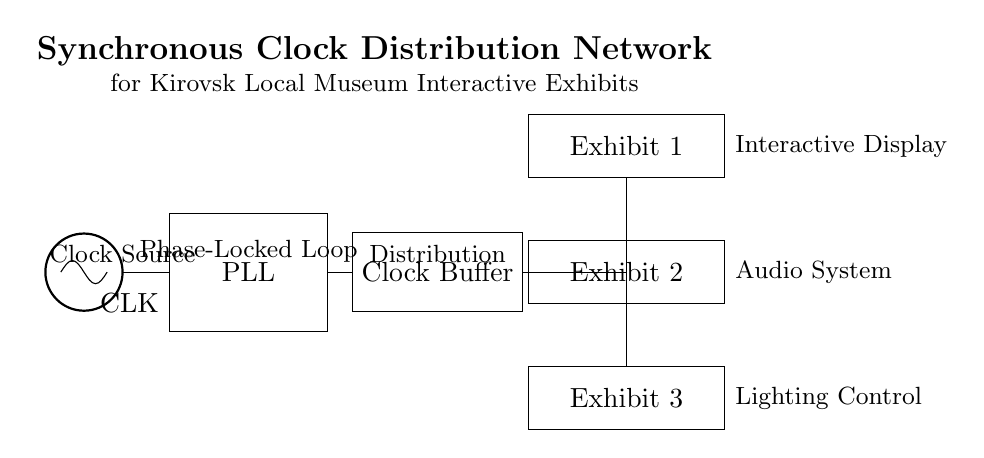What is the main source of the clock signal? The main source of the clock signal is the oscillator labeled "CLK". This component generates the clock signal used to synchronize operations in the circuit.
Answer: CLK What component is used for clock signal adjustment? The component responsible for clock signal adjustment in the circuit is the Phase-Locked Loop (PLL). The PLL synchronizes the frequency of the output clock signal with that of the input signal from the oscillator.
Answer: Phase-Locked Loop How many exhibits are connected to the clock buffer? There are three exhibits connected to the clock buffer: Exhibit 1, Exhibit 2, and Exhibit 3. The circuit shows distribution lines leading from the clock buffer to each exhibit, indicating they all receive the clock signal.
Answer: 3 What is the function of the clock buffer in this circuit? The function of the clock buffer is to strengthen and distribute the clock signal to multiple destinations. It ensures that the clock signal maintains its integrity as it is distributed to the exhibits, allowing them to operate in sync.
Answer: Distribution Which exhibit is associated with the audio system? Exhibit 2 is associated with the audio system, as indicated by its label in the circuit diagram. It shows that this specific exhibit receives the clock signal for its operation.
Answer: Exhibit 2 Why is a Phase-Locked Loop used in this circuit? A Phase-Locked Loop is used to maintain phase and frequency synchronization between the incoming clock from the oscillator and the output clock used by the exhibits. This ensures that all interactive elements operate in a synchronized manner, preventing timing issues.
Answer: Phase-Locked Loop What type of circuit is illustrated in this diagram? The type of circuit illustrated in this diagram is a synchronous clock distribution network. It is specifically designed for distributing a synchronized clock signal to multiple interactive exhibits in the local museum.
Answer: Synchronous clock distribution network 